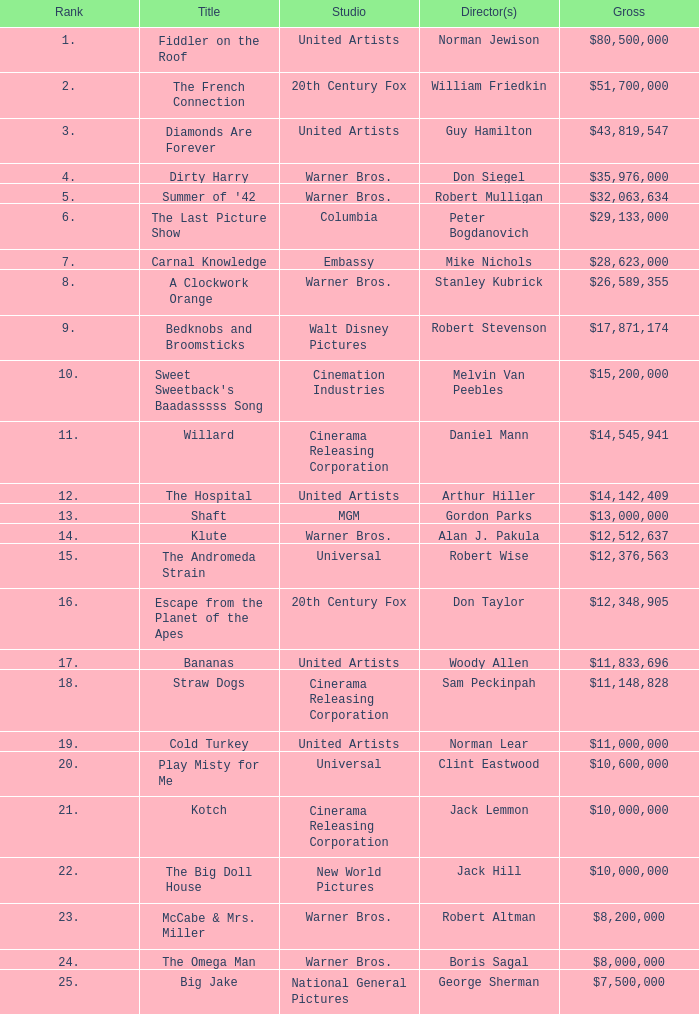What is the standing of the big doll house? 22.0. 